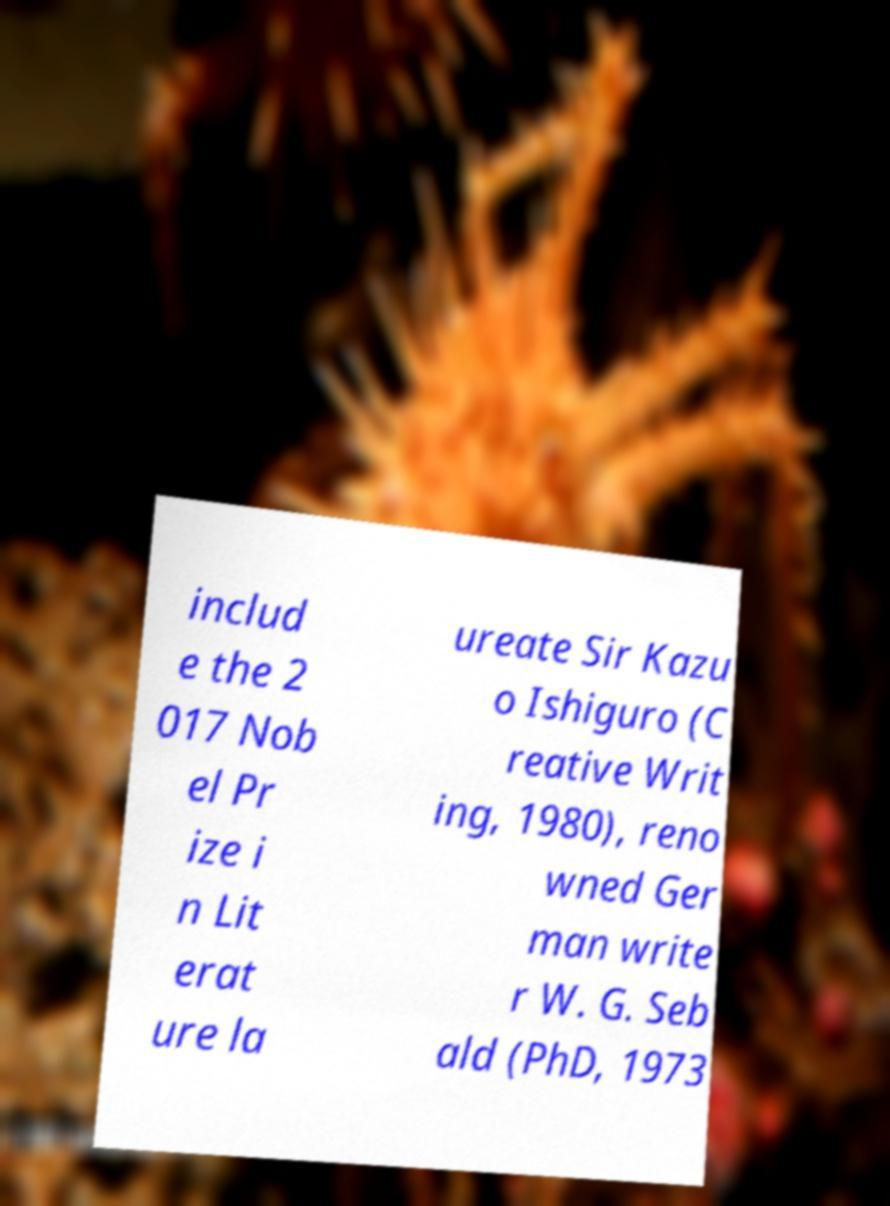There's text embedded in this image that I need extracted. Can you transcribe it verbatim? includ e the 2 017 Nob el Pr ize i n Lit erat ure la ureate Sir Kazu o Ishiguro (C reative Writ ing, 1980), reno wned Ger man write r W. G. Seb ald (PhD, 1973 